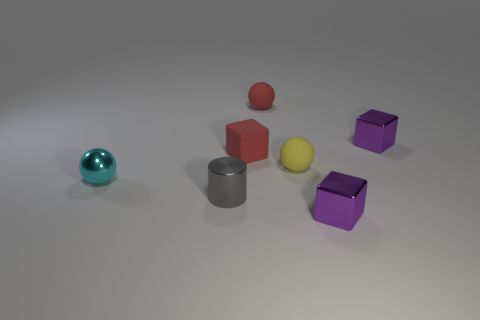Add 2 large green matte blocks. How many objects exist? 9 Subtract all matte spheres. How many spheres are left? 1 Subtract all green cylinders. Subtract all gray spheres. How many cylinders are left? 1 Subtract all red cubes. How many red balls are left? 1 Subtract all cyan shiny objects. Subtract all small blue cylinders. How many objects are left? 6 Add 2 small rubber objects. How many small rubber objects are left? 5 Add 5 cyan shiny objects. How many cyan shiny objects exist? 6 Subtract all purple blocks. How many blocks are left? 1 Subtract 0 green blocks. How many objects are left? 7 Subtract all cylinders. How many objects are left? 6 